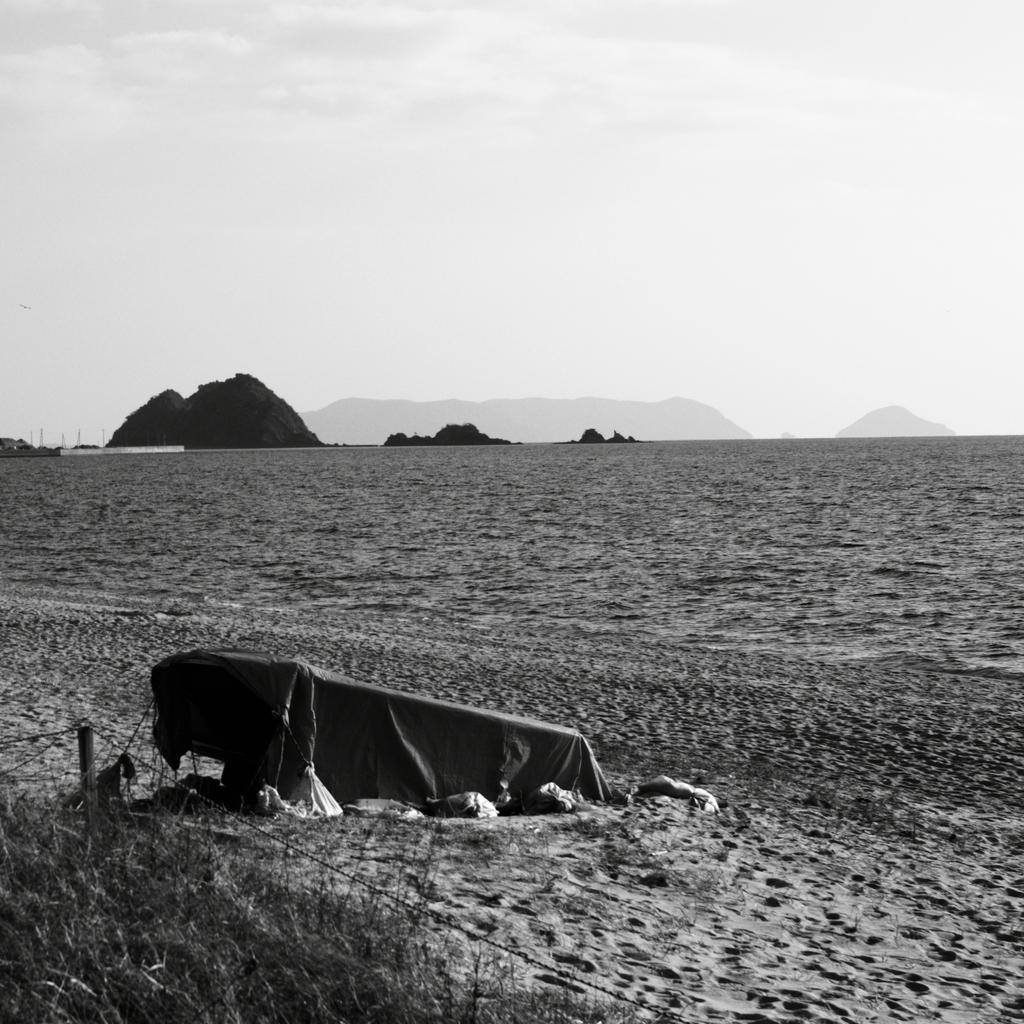What is the color scheme of the image? The image is black and white. What type of terrain can be seen in the image? There is a land in the image. What geographical feature is visible in the background? There are mountains in the background of the image. What object is located on the left side of the image? There is a cloth on the left side of the image. How many kittens are playing with the liquid in the image? There are no kittens or liquid present in the image. What type of giraffe can be seen in the background of the image? There are no giraffes present in the image; it features mountains in the background. 